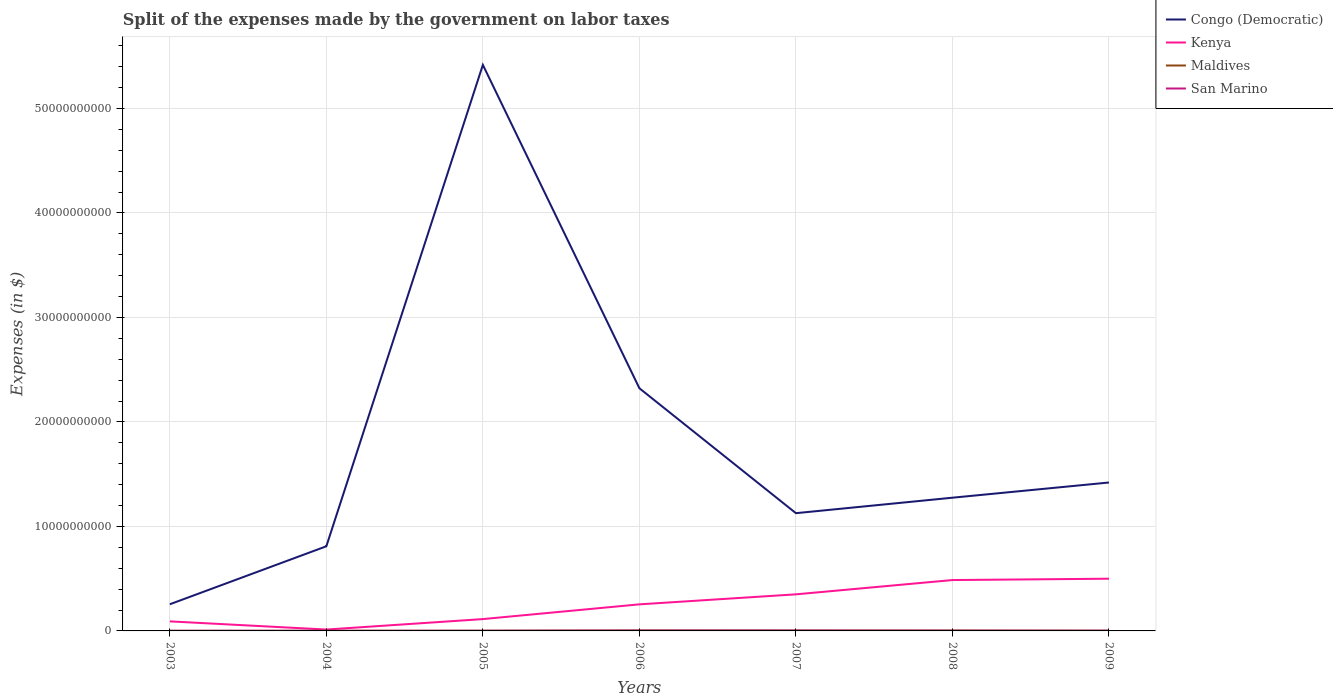Across all years, what is the maximum expenses made by the government on labor taxes in San Marino?
Keep it short and to the point. 1.21e+07. In which year was the expenses made by the government on labor taxes in Congo (Democratic) maximum?
Provide a succinct answer. 2003. What is the total expenses made by the government on labor taxes in San Marino in the graph?
Give a very brief answer. -1.90e+06. What is the difference between the highest and the second highest expenses made by the government on labor taxes in San Marino?
Your answer should be very brief. 1.99e+07. How many lines are there?
Provide a short and direct response. 4. Are the values on the major ticks of Y-axis written in scientific E-notation?
Ensure brevity in your answer.  No. How many legend labels are there?
Offer a very short reply. 4. What is the title of the graph?
Your response must be concise. Split of the expenses made by the government on labor taxes. Does "Latin America(developing only)" appear as one of the legend labels in the graph?
Offer a very short reply. No. What is the label or title of the X-axis?
Keep it short and to the point. Years. What is the label or title of the Y-axis?
Provide a short and direct response. Expenses (in $). What is the Expenses (in $) of Congo (Democratic) in 2003?
Ensure brevity in your answer.  2.55e+09. What is the Expenses (in $) of Kenya in 2003?
Your response must be concise. 9.14e+08. What is the Expenses (in $) of Maldives in 2003?
Your answer should be compact. 1.06e+07. What is the Expenses (in $) in San Marino in 2003?
Your answer should be very brief. 1.21e+07. What is the Expenses (in $) in Congo (Democratic) in 2004?
Offer a terse response. 8.10e+09. What is the Expenses (in $) in Kenya in 2004?
Keep it short and to the point. 1.31e+08. What is the Expenses (in $) of Maldives in 2004?
Give a very brief answer. 1.22e+07. What is the Expenses (in $) of San Marino in 2004?
Your response must be concise. 1.28e+07. What is the Expenses (in $) in Congo (Democratic) in 2005?
Give a very brief answer. 5.42e+1. What is the Expenses (in $) in Kenya in 2005?
Offer a very short reply. 1.13e+09. What is the Expenses (in $) of Maldives in 2005?
Give a very brief answer. 2.02e+07. What is the Expenses (in $) of San Marino in 2005?
Provide a succinct answer. 1.40e+07. What is the Expenses (in $) of Congo (Democratic) in 2006?
Your response must be concise. 2.32e+1. What is the Expenses (in $) in Kenya in 2006?
Keep it short and to the point. 2.54e+09. What is the Expenses (in $) in Maldives in 2006?
Ensure brevity in your answer.  4.56e+07. What is the Expenses (in $) in San Marino in 2006?
Your response must be concise. 2.84e+07. What is the Expenses (in $) of Congo (Democratic) in 2007?
Give a very brief answer. 1.13e+1. What is the Expenses (in $) of Kenya in 2007?
Give a very brief answer. 3.50e+09. What is the Expenses (in $) of Maldives in 2007?
Offer a terse response. 4.18e+07. What is the Expenses (in $) of San Marino in 2007?
Keep it short and to the point. 3.20e+07. What is the Expenses (in $) of Congo (Democratic) in 2008?
Your answer should be compact. 1.27e+1. What is the Expenses (in $) in Kenya in 2008?
Offer a very short reply. 4.87e+09. What is the Expenses (in $) of Maldives in 2008?
Your response must be concise. 3.97e+07. What is the Expenses (in $) of San Marino in 2008?
Make the answer very short. 1.87e+07. What is the Expenses (in $) in Congo (Democratic) in 2009?
Your answer should be compact. 1.42e+1. What is the Expenses (in $) in Kenya in 2009?
Offer a very short reply. 5.00e+09. What is the Expenses (in $) of Maldives in 2009?
Ensure brevity in your answer.  2.71e+07. What is the Expenses (in $) in San Marino in 2009?
Give a very brief answer. 1.88e+07. Across all years, what is the maximum Expenses (in $) in Congo (Democratic)?
Give a very brief answer. 5.42e+1. Across all years, what is the maximum Expenses (in $) of Kenya?
Your answer should be very brief. 5.00e+09. Across all years, what is the maximum Expenses (in $) of Maldives?
Give a very brief answer. 4.56e+07. Across all years, what is the maximum Expenses (in $) of San Marino?
Keep it short and to the point. 3.20e+07. Across all years, what is the minimum Expenses (in $) in Congo (Democratic)?
Offer a very short reply. 2.55e+09. Across all years, what is the minimum Expenses (in $) of Kenya?
Your answer should be very brief. 1.31e+08. Across all years, what is the minimum Expenses (in $) of Maldives?
Make the answer very short. 1.06e+07. Across all years, what is the minimum Expenses (in $) of San Marino?
Your response must be concise. 1.21e+07. What is the total Expenses (in $) in Congo (Democratic) in the graph?
Offer a terse response. 1.26e+11. What is the total Expenses (in $) of Kenya in the graph?
Offer a very short reply. 1.81e+1. What is the total Expenses (in $) of Maldives in the graph?
Your answer should be very brief. 1.97e+08. What is the total Expenses (in $) in San Marino in the graph?
Your response must be concise. 1.37e+08. What is the difference between the Expenses (in $) of Congo (Democratic) in 2003 and that in 2004?
Provide a succinct answer. -5.55e+09. What is the difference between the Expenses (in $) of Kenya in 2003 and that in 2004?
Your response must be concise. 7.83e+08. What is the difference between the Expenses (in $) in Maldives in 2003 and that in 2004?
Your answer should be compact. -1.60e+06. What is the difference between the Expenses (in $) of San Marino in 2003 and that in 2004?
Your answer should be compact. -7.01e+05. What is the difference between the Expenses (in $) in Congo (Democratic) in 2003 and that in 2005?
Offer a terse response. -5.16e+1. What is the difference between the Expenses (in $) of Kenya in 2003 and that in 2005?
Your answer should be compact. -2.19e+08. What is the difference between the Expenses (in $) in Maldives in 2003 and that in 2005?
Your answer should be compact. -9.60e+06. What is the difference between the Expenses (in $) in San Marino in 2003 and that in 2005?
Ensure brevity in your answer.  -1.90e+06. What is the difference between the Expenses (in $) of Congo (Democratic) in 2003 and that in 2006?
Ensure brevity in your answer.  -2.07e+1. What is the difference between the Expenses (in $) in Kenya in 2003 and that in 2006?
Give a very brief answer. -1.63e+09. What is the difference between the Expenses (in $) in Maldives in 2003 and that in 2006?
Offer a terse response. -3.50e+07. What is the difference between the Expenses (in $) in San Marino in 2003 and that in 2006?
Your response must be concise. -1.63e+07. What is the difference between the Expenses (in $) in Congo (Democratic) in 2003 and that in 2007?
Make the answer very short. -8.72e+09. What is the difference between the Expenses (in $) of Kenya in 2003 and that in 2007?
Provide a short and direct response. -2.59e+09. What is the difference between the Expenses (in $) in Maldives in 2003 and that in 2007?
Offer a very short reply. -3.12e+07. What is the difference between the Expenses (in $) of San Marino in 2003 and that in 2007?
Your answer should be compact. -1.99e+07. What is the difference between the Expenses (in $) in Congo (Democratic) in 2003 and that in 2008?
Ensure brevity in your answer.  -1.02e+1. What is the difference between the Expenses (in $) in Kenya in 2003 and that in 2008?
Offer a terse response. -3.95e+09. What is the difference between the Expenses (in $) of Maldives in 2003 and that in 2008?
Offer a terse response. -2.91e+07. What is the difference between the Expenses (in $) in San Marino in 2003 and that in 2008?
Ensure brevity in your answer.  -6.58e+06. What is the difference between the Expenses (in $) in Congo (Democratic) in 2003 and that in 2009?
Give a very brief answer. -1.17e+1. What is the difference between the Expenses (in $) of Kenya in 2003 and that in 2009?
Make the answer very short. -4.08e+09. What is the difference between the Expenses (in $) of Maldives in 2003 and that in 2009?
Your answer should be very brief. -1.65e+07. What is the difference between the Expenses (in $) of San Marino in 2003 and that in 2009?
Offer a terse response. -6.68e+06. What is the difference between the Expenses (in $) of Congo (Democratic) in 2004 and that in 2005?
Ensure brevity in your answer.  -4.61e+1. What is the difference between the Expenses (in $) of Kenya in 2004 and that in 2005?
Provide a short and direct response. -1.00e+09. What is the difference between the Expenses (in $) of Maldives in 2004 and that in 2005?
Ensure brevity in your answer.  -8.00e+06. What is the difference between the Expenses (in $) in San Marino in 2004 and that in 2005?
Make the answer very short. -1.20e+06. What is the difference between the Expenses (in $) in Congo (Democratic) in 2004 and that in 2006?
Provide a succinct answer. -1.51e+1. What is the difference between the Expenses (in $) in Kenya in 2004 and that in 2006?
Make the answer very short. -2.41e+09. What is the difference between the Expenses (in $) of Maldives in 2004 and that in 2006?
Provide a short and direct response. -3.34e+07. What is the difference between the Expenses (in $) in San Marino in 2004 and that in 2006?
Provide a succinct answer. -1.56e+07. What is the difference between the Expenses (in $) in Congo (Democratic) in 2004 and that in 2007?
Give a very brief answer. -3.17e+09. What is the difference between the Expenses (in $) of Kenya in 2004 and that in 2007?
Keep it short and to the point. -3.37e+09. What is the difference between the Expenses (in $) of Maldives in 2004 and that in 2007?
Give a very brief answer. -2.96e+07. What is the difference between the Expenses (in $) of San Marino in 2004 and that in 2007?
Offer a terse response. -1.92e+07. What is the difference between the Expenses (in $) of Congo (Democratic) in 2004 and that in 2008?
Your response must be concise. -4.65e+09. What is the difference between the Expenses (in $) of Kenya in 2004 and that in 2008?
Provide a succinct answer. -4.74e+09. What is the difference between the Expenses (in $) of Maldives in 2004 and that in 2008?
Ensure brevity in your answer.  -2.75e+07. What is the difference between the Expenses (in $) in San Marino in 2004 and that in 2008?
Provide a succinct answer. -5.88e+06. What is the difference between the Expenses (in $) in Congo (Democratic) in 2004 and that in 2009?
Provide a succinct answer. -6.10e+09. What is the difference between the Expenses (in $) in Kenya in 2004 and that in 2009?
Your answer should be compact. -4.87e+09. What is the difference between the Expenses (in $) of Maldives in 2004 and that in 2009?
Offer a terse response. -1.49e+07. What is the difference between the Expenses (in $) in San Marino in 2004 and that in 2009?
Ensure brevity in your answer.  -5.98e+06. What is the difference between the Expenses (in $) in Congo (Democratic) in 2005 and that in 2006?
Your answer should be very brief. 3.09e+1. What is the difference between the Expenses (in $) in Kenya in 2005 and that in 2006?
Provide a succinct answer. -1.41e+09. What is the difference between the Expenses (in $) of Maldives in 2005 and that in 2006?
Offer a terse response. -2.54e+07. What is the difference between the Expenses (in $) of San Marino in 2005 and that in 2006?
Offer a very short reply. -1.44e+07. What is the difference between the Expenses (in $) in Congo (Democratic) in 2005 and that in 2007?
Provide a succinct answer. 4.29e+1. What is the difference between the Expenses (in $) in Kenya in 2005 and that in 2007?
Your answer should be compact. -2.37e+09. What is the difference between the Expenses (in $) of Maldives in 2005 and that in 2007?
Give a very brief answer. -2.16e+07. What is the difference between the Expenses (in $) of San Marino in 2005 and that in 2007?
Your answer should be very brief. -1.80e+07. What is the difference between the Expenses (in $) in Congo (Democratic) in 2005 and that in 2008?
Make the answer very short. 4.14e+1. What is the difference between the Expenses (in $) in Kenya in 2005 and that in 2008?
Provide a succinct answer. -3.74e+09. What is the difference between the Expenses (in $) in Maldives in 2005 and that in 2008?
Provide a short and direct response. -1.95e+07. What is the difference between the Expenses (in $) of San Marino in 2005 and that in 2008?
Provide a succinct answer. -4.68e+06. What is the difference between the Expenses (in $) of Congo (Democratic) in 2005 and that in 2009?
Your response must be concise. 4.00e+1. What is the difference between the Expenses (in $) in Kenya in 2005 and that in 2009?
Offer a terse response. -3.86e+09. What is the difference between the Expenses (in $) of Maldives in 2005 and that in 2009?
Provide a succinct answer. -6.90e+06. What is the difference between the Expenses (in $) in San Marino in 2005 and that in 2009?
Keep it short and to the point. -4.78e+06. What is the difference between the Expenses (in $) in Congo (Democratic) in 2006 and that in 2007?
Offer a very short reply. 1.20e+1. What is the difference between the Expenses (in $) of Kenya in 2006 and that in 2007?
Ensure brevity in your answer.  -9.58e+08. What is the difference between the Expenses (in $) of Maldives in 2006 and that in 2007?
Provide a short and direct response. 3.80e+06. What is the difference between the Expenses (in $) in San Marino in 2006 and that in 2007?
Make the answer very short. -3.56e+06. What is the difference between the Expenses (in $) in Congo (Democratic) in 2006 and that in 2008?
Make the answer very short. 1.05e+1. What is the difference between the Expenses (in $) in Kenya in 2006 and that in 2008?
Your answer should be very brief. -2.33e+09. What is the difference between the Expenses (in $) of Maldives in 2006 and that in 2008?
Offer a terse response. 5.90e+06. What is the difference between the Expenses (in $) of San Marino in 2006 and that in 2008?
Make the answer very short. 9.73e+06. What is the difference between the Expenses (in $) of Congo (Democratic) in 2006 and that in 2009?
Offer a terse response. 9.02e+09. What is the difference between the Expenses (in $) of Kenya in 2006 and that in 2009?
Offer a very short reply. -2.45e+09. What is the difference between the Expenses (in $) of Maldives in 2006 and that in 2009?
Make the answer very short. 1.85e+07. What is the difference between the Expenses (in $) of San Marino in 2006 and that in 2009?
Your answer should be compact. 9.63e+06. What is the difference between the Expenses (in $) of Congo (Democratic) in 2007 and that in 2008?
Offer a very short reply. -1.48e+09. What is the difference between the Expenses (in $) of Kenya in 2007 and that in 2008?
Provide a short and direct response. -1.37e+09. What is the difference between the Expenses (in $) of Maldives in 2007 and that in 2008?
Your answer should be compact. 2.10e+06. What is the difference between the Expenses (in $) in San Marino in 2007 and that in 2008?
Offer a very short reply. 1.33e+07. What is the difference between the Expenses (in $) in Congo (Democratic) in 2007 and that in 2009?
Give a very brief answer. -2.93e+09. What is the difference between the Expenses (in $) of Kenya in 2007 and that in 2009?
Make the answer very short. -1.50e+09. What is the difference between the Expenses (in $) in Maldives in 2007 and that in 2009?
Your answer should be compact. 1.47e+07. What is the difference between the Expenses (in $) in San Marino in 2007 and that in 2009?
Your answer should be very brief. 1.32e+07. What is the difference between the Expenses (in $) in Congo (Democratic) in 2008 and that in 2009?
Provide a succinct answer. -1.45e+09. What is the difference between the Expenses (in $) of Kenya in 2008 and that in 2009?
Your answer should be compact. -1.29e+08. What is the difference between the Expenses (in $) in Maldives in 2008 and that in 2009?
Offer a very short reply. 1.26e+07. What is the difference between the Expenses (in $) of San Marino in 2008 and that in 2009?
Keep it short and to the point. -9.65e+04. What is the difference between the Expenses (in $) in Congo (Democratic) in 2003 and the Expenses (in $) in Kenya in 2004?
Offer a very short reply. 2.42e+09. What is the difference between the Expenses (in $) of Congo (Democratic) in 2003 and the Expenses (in $) of Maldives in 2004?
Make the answer very short. 2.54e+09. What is the difference between the Expenses (in $) of Congo (Democratic) in 2003 and the Expenses (in $) of San Marino in 2004?
Ensure brevity in your answer.  2.54e+09. What is the difference between the Expenses (in $) of Kenya in 2003 and the Expenses (in $) of Maldives in 2004?
Offer a very short reply. 9.01e+08. What is the difference between the Expenses (in $) of Kenya in 2003 and the Expenses (in $) of San Marino in 2004?
Give a very brief answer. 9.01e+08. What is the difference between the Expenses (in $) of Maldives in 2003 and the Expenses (in $) of San Marino in 2004?
Provide a succinct answer. -2.20e+06. What is the difference between the Expenses (in $) in Congo (Democratic) in 2003 and the Expenses (in $) in Kenya in 2005?
Give a very brief answer. 1.42e+09. What is the difference between the Expenses (in $) of Congo (Democratic) in 2003 and the Expenses (in $) of Maldives in 2005?
Give a very brief answer. 2.53e+09. What is the difference between the Expenses (in $) of Congo (Democratic) in 2003 and the Expenses (in $) of San Marino in 2005?
Your answer should be very brief. 2.54e+09. What is the difference between the Expenses (in $) of Kenya in 2003 and the Expenses (in $) of Maldives in 2005?
Your response must be concise. 8.93e+08. What is the difference between the Expenses (in $) in Kenya in 2003 and the Expenses (in $) in San Marino in 2005?
Give a very brief answer. 9.00e+08. What is the difference between the Expenses (in $) of Maldives in 2003 and the Expenses (in $) of San Marino in 2005?
Offer a terse response. -3.40e+06. What is the difference between the Expenses (in $) in Congo (Democratic) in 2003 and the Expenses (in $) in Kenya in 2006?
Offer a terse response. 7.52e+06. What is the difference between the Expenses (in $) in Congo (Democratic) in 2003 and the Expenses (in $) in Maldives in 2006?
Ensure brevity in your answer.  2.50e+09. What is the difference between the Expenses (in $) of Congo (Democratic) in 2003 and the Expenses (in $) of San Marino in 2006?
Make the answer very short. 2.52e+09. What is the difference between the Expenses (in $) of Kenya in 2003 and the Expenses (in $) of Maldives in 2006?
Provide a short and direct response. 8.68e+08. What is the difference between the Expenses (in $) of Kenya in 2003 and the Expenses (in $) of San Marino in 2006?
Offer a very short reply. 8.85e+08. What is the difference between the Expenses (in $) of Maldives in 2003 and the Expenses (in $) of San Marino in 2006?
Your answer should be compact. -1.78e+07. What is the difference between the Expenses (in $) in Congo (Democratic) in 2003 and the Expenses (in $) in Kenya in 2007?
Offer a terse response. -9.50e+08. What is the difference between the Expenses (in $) in Congo (Democratic) in 2003 and the Expenses (in $) in Maldives in 2007?
Your answer should be compact. 2.51e+09. What is the difference between the Expenses (in $) of Congo (Democratic) in 2003 and the Expenses (in $) of San Marino in 2007?
Your answer should be very brief. 2.52e+09. What is the difference between the Expenses (in $) in Kenya in 2003 and the Expenses (in $) in Maldives in 2007?
Make the answer very short. 8.72e+08. What is the difference between the Expenses (in $) in Kenya in 2003 and the Expenses (in $) in San Marino in 2007?
Your answer should be compact. 8.82e+08. What is the difference between the Expenses (in $) in Maldives in 2003 and the Expenses (in $) in San Marino in 2007?
Offer a terse response. -2.14e+07. What is the difference between the Expenses (in $) in Congo (Democratic) in 2003 and the Expenses (in $) in Kenya in 2008?
Ensure brevity in your answer.  -2.32e+09. What is the difference between the Expenses (in $) in Congo (Democratic) in 2003 and the Expenses (in $) in Maldives in 2008?
Offer a very short reply. 2.51e+09. What is the difference between the Expenses (in $) in Congo (Democratic) in 2003 and the Expenses (in $) in San Marino in 2008?
Keep it short and to the point. 2.53e+09. What is the difference between the Expenses (in $) in Kenya in 2003 and the Expenses (in $) in Maldives in 2008?
Offer a terse response. 8.74e+08. What is the difference between the Expenses (in $) in Kenya in 2003 and the Expenses (in $) in San Marino in 2008?
Offer a terse response. 8.95e+08. What is the difference between the Expenses (in $) of Maldives in 2003 and the Expenses (in $) of San Marino in 2008?
Provide a short and direct response. -8.08e+06. What is the difference between the Expenses (in $) of Congo (Democratic) in 2003 and the Expenses (in $) of Kenya in 2009?
Provide a succinct answer. -2.45e+09. What is the difference between the Expenses (in $) of Congo (Democratic) in 2003 and the Expenses (in $) of Maldives in 2009?
Provide a short and direct response. 2.52e+09. What is the difference between the Expenses (in $) of Congo (Democratic) in 2003 and the Expenses (in $) of San Marino in 2009?
Your response must be concise. 2.53e+09. What is the difference between the Expenses (in $) of Kenya in 2003 and the Expenses (in $) of Maldives in 2009?
Provide a short and direct response. 8.87e+08. What is the difference between the Expenses (in $) of Kenya in 2003 and the Expenses (in $) of San Marino in 2009?
Offer a terse response. 8.95e+08. What is the difference between the Expenses (in $) in Maldives in 2003 and the Expenses (in $) in San Marino in 2009?
Keep it short and to the point. -8.18e+06. What is the difference between the Expenses (in $) of Congo (Democratic) in 2004 and the Expenses (in $) of Kenya in 2005?
Offer a terse response. 6.97e+09. What is the difference between the Expenses (in $) of Congo (Democratic) in 2004 and the Expenses (in $) of Maldives in 2005?
Offer a terse response. 8.08e+09. What is the difference between the Expenses (in $) in Congo (Democratic) in 2004 and the Expenses (in $) in San Marino in 2005?
Ensure brevity in your answer.  8.08e+09. What is the difference between the Expenses (in $) in Kenya in 2004 and the Expenses (in $) in Maldives in 2005?
Make the answer very short. 1.11e+08. What is the difference between the Expenses (in $) in Kenya in 2004 and the Expenses (in $) in San Marino in 2005?
Offer a very short reply. 1.17e+08. What is the difference between the Expenses (in $) of Maldives in 2004 and the Expenses (in $) of San Marino in 2005?
Provide a short and direct response. -1.80e+06. What is the difference between the Expenses (in $) in Congo (Democratic) in 2004 and the Expenses (in $) in Kenya in 2006?
Give a very brief answer. 5.56e+09. What is the difference between the Expenses (in $) of Congo (Democratic) in 2004 and the Expenses (in $) of Maldives in 2006?
Your answer should be compact. 8.05e+09. What is the difference between the Expenses (in $) in Congo (Democratic) in 2004 and the Expenses (in $) in San Marino in 2006?
Your answer should be very brief. 8.07e+09. What is the difference between the Expenses (in $) of Kenya in 2004 and the Expenses (in $) of Maldives in 2006?
Your answer should be very brief. 8.54e+07. What is the difference between the Expenses (in $) of Kenya in 2004 and the Expenses (in $) of San Marino in 2006?
Ensure brevity in your answer.  1.03e+08. What is the difference between the Expenses (in $) in Maldives in 2004 and the Expenses (in $) in San Marino in 2006?
Your response must be concise. -1.62e+07. What is the difference between the Expenses (in $) of Congo (Democratic) in 2004 and the Expenses (in $) of Kenya in 2007?
Your response must be concise. 4.60e+09. What is the difference between the Expenses (in $) of Congo (Democratic) in 2004 and the Expenses (in $) of Maldives in 2007?
Provide a short and direct response. 8.06e+09. What is the difference between the Expenses (in $) of Congo (Democratic) in 2004 and the Expenses (in $) of San Marino in 2007?
Make the answer very short. 8.07e+09. What is the difference between the Expenses (in $) in Kenya in 2004 and the Expenses (in $) in Maldives in 2007?
Your answer should be very brief. 8.92e+07. What is the difference between the Expenses (in $) of Kenya in 2004 and the Expenses (in $) of San Marino in 2007?
Your answer should be very brief. 9.90e+07. What is the difference between the Expenses (in $) of Maldives in 2004 and the Expenses (in $) of San Marino in 2007?
Keep it short and to the point. -1.98e+07. What is the difference between the Expenses (in $) in Congo (Democratic) in 2004 and the Expenses (in $) in Kenya in 2008?
Your answer should be compact. 3.23e+09. What is the difference between the Expenses (in $) in Congo (Democratic) in 2004 and the Expenses (in $) in Maldives in 2008?
Provide a succinct answer. 8.06e+09. What is the difference between the Expenses (in $) of Congo (Democratic) in 2004 and the Expenses (in $) of San Marino in 2008?
Your response must be concise. 8.08e+09. What is the difference between the Expenses (in $) of Kenya in 2004 and the Expenses (in $) of Maldives in 2008?
Your answer should be very brief. 9.13e+07. What is the difference between the Expenses (in $) in Kenya in 2004 and the Expenses (in $) in San Marino in 2008?
Your answer should be very brief. 1.12e+08. What is the difference between the Expenses (in $) in Maldives in 2004 and the Expenses (in $) in San Marino in 2008?
Give a very brief answer. -6.48e+06. What is the difference between the Expenses (in $) in Congo (Democratic) in 2004 and the Expenses (in $) in Kenya in 2009?
Your answer should be compact. 3.10e+09. What is the difference between the Expenses (in $) in Congo (Democratic) in 2004 and the Expenses (in $) in Maldives in 2009?
Make the answer very short. 8.07e+09. What is the difference between the Expenses (in $) in Congo (Democratic) in 2004 and the Expenses (in $) in San Marino in 2009?
Ensure brevity in your answer.  8.08e+09. What is the difference between the Expenses (in $) in Kenya in 2004 and the Expenses (in $) in Maldives in 2009?
Your answer should be very brief. 1.04e+08. What is the difference between the Expenses (in $) of Kenya in 2004 and the Expenses (in $) of San Marino in 2009?
Ensure brevity in your answer.  1.12e+08. What is the difference between the Expenses (in $) of Maldives in 2004 and the Expenses (in $) of San Marino in 2009?
Provide a succinct answer. -6.58e+06. What is the difference between the Expenses (in $) in Congo (Democratic) in 2005 and the Expenses (in $) in Kenya in 2006?
Provide a succinct answer. 5.16e+1. What is the difference between the Expenses (in $) of Congo (Democratic) in 2005 and the Expenses (in $) of Maldives in 2006?
Your answer should be very brief. 5.41e+1. What is the difference between the Expenses (in $) in Congo (Democratic) in 2005 and the Expenses (in $) in San Marino in 2006?
Your response must be concise. 5.41e+1. What is the difference between the Expenses (in $) in Kenya in 2005 and the Expenses (in $) in Maldives in 2006?
Offer a very short reply. 1.09e+09. What is the difference between the Expenses (in $) in Kenya in 2005 and the Expenses (in $) in San Marino in 2006?
Provide a short and direct response. 1.10e+09. What is the difference between the Expenses (in $) in Maldives in 2005 and the Expenses (in $) in San Marino in 2006?
Give a very brief answer. -8.21e+06. What is the difference between the Expenses (in $) of Congo (Democratic) in 2005 and the Expenses (in $) of Kenya in 2007?
Your response must be concise. 5.07e+1. What is the difference between the Expenses (in $) in Congo (Democratic) in 2005 and the Expenses (in $) in Maldives in 2007?
Your answer should be very brief. 5.41e+1. What is the difference between the Expenses (in $) of Congo (Democratic) in 2005 and the Expenses (in $) of San Marino in 2007?
Provide a succinct answer. 5.41e+1. What is the difference between the Expenses (in $) in Kenya in 2005 and the Expenses (in $) in Maldives in 2007?
Your response must be concise. 1.09e+09. What is the difference between the Expenses (in $) of Kenya in 2005 and the Expenses (in $) of San Marino in 2007?
Offer a very short reply. 1.10e+09. What is the difference between the Expenses (in $) in Maldives in 2005 and the Expenses (in $) in San Marino in 2007?
Ensure brevity in your answer.  -1.18e+07. What is the difference between the Expenses (in $) in Congo (Democratic) in 2005 and the Expenses (in $) in Kenya in 2008?
Your answer should be compact. 4.93e+1. What is the difference between the Expenses (in $) in Congo (Democratic) in 2005 and the Expenses (in $) in Maldives in 2008?
Your response must be concise. 5.41e+1. What is the difference between the Expenses (in $) of Congo (Democratic) in 2005 and the Expenses (in $) of San Marino in 2008?
Offer a very short reply. 5.41e+1. What is the difference between the Expenses (in $) in Kenya in 2005 and the Expenses (in $) in Maldives in 2008?
Give a very brief answer. 1.09e+09. What is the difference between the Expenses (in $) of Kenya in 2005 and the Expenses (in $) of San Marino in 2008?
Provide a short and direct response. 1.11e+09. What is the difference between the Expenses (in $) in Maldives in 2005 and the Expenses (in $) in San Marino in 2008?
Make the answer very short. 1.52e+06. What is the difference between the Expenses (in $) in Congo (Democratic) in 2005 and the Expenses (in $) in Kenya in 2009?
Your response must be concise. 4.92e+1. What is the difference between the Expenses (in $) in Congo (Democratic) in 2005 and the Expenses (in $) in Maldives in 2009?
Make the answer very short. 5.41e+1. What is the difference between the Expenses (in $) of Congo (Democratic) in 2005 and the Expenses (in $) of San Marino in 2009?
Offer a very short reply. 5.41e+1. What is the difference between the Expenses (in $) of Kenya in 2005 and the Expenses (in $) of Maldives in 2009?
Offer a very short reply. 1.11e+09. What is the difference between the Expenses (in $) of Kenya in 2005 and the Expenses (in $) of San Marino in 2009?
Give a very brief answer. 1.11e+09. What is the difference between the Expenses (in $) of Maldives in 2005 and the Expenses (in $) of San Marino in 2009?
Provide a short and direct response. 1.42e+06. What is the difference between the Expenses (in $) in Congo (Democratic) in 2006 and the Expenses (in $) in Kenya in 2007?
Keep it short and to the point. 1.97e+1. What is the difference between the Expenses (in $) in Congo (Democratic) in 2006 and the Expenses (in $) in Maldives in 2007?
Ensure brevity in your answer.  2.32e+1. What is the difference between the Expenses (in $) in Congo (Democratic) in 2006 and the Expenses (in $) in San Marino in 2007?
Keep it short and to the point. 2.32e+1. What is the difference between the Expenses (in $) of Kenya in 2006 and the Expenses (in $) of Maldives in 2007?
Your answer should be compact. 2.50e+09. What is the difference between the Expenses (in $) in Kenya in 2006 and the Expenses (in $) in San Marino in 2007?
Ensure brevity in your answer.  2.51e+09. What is the difference between the Expenses (in $) of Maldives in 2006 and the Expenses (in $) of San Marino in 2007?
Provide a short and direct response. 1.36e+07. What is the difference between the Expenses (in $) of Congo (Democratic) in 2006 and the Expenses (in $) of Kenya in 2008?
Your response must be concise. 1.84e+1. What is the difference between the Expenses (in $) in Congo (Democratic) in 2006 and the Expenses (in $) in Maldives in 2008?
Give a very brief answer. 2.32e+1. What is the difference between the Expenses (in $) in Congo (Democratic) in 2006 and the Expenses (in $) in San Marino in 2008?
Offer a very short reply. 2.32e+1. What is the difference between the Expenses (in $) of Kenya in 2006 and the Expenses (in $) of Maldives in 2008?
Ensure brevity in your answer.  2.50e+09. What is the difference between the Expenses (in $) of Kenya in 2006 and the Expenses (in $) of San Marino in 2008?
Make the answer very short. 2.52e+09. What is the difference between the Expenses (in $) in Maldives in 2006 and the Expenses (in $) in San Marino in 2008?
Your answer should be compact. 2.69e+07. What is the difference between the Expenses (in $) in Congo (Democratic) in 2006 and the Expenses (in $) in Kenya in 2009?
Provide a short and direct response. 1.82e+1. What is the difference between the Expenses (in $) in Congo (Democratic) in 2006 and the Expenses (in $) in Maldives in 2009?
Keep it short and to the point. 2.32e+1. What is the difference between the Expenses (in $) in Congo (Democratic) in 2006 and the Expenses (in $) in San Marino in 2009?
Give a very brief answer. 2.32e+1. What is the difference between the Expenses (in $) in Kenya in 2006 and the Expenses (in $) in Maldives in 2009?
Offer a very short reply. 2.52e+09. What is the difference between the Expenses (in $) of Kenya in 2006 and the Expenses (in $) of San Marino in 2009?
Ensure brevity in your answer.  2.52e+09. What is the difference between the Expenses (in $) of Maldives in 2006 and the Expenses (in $) of San Marino in 2009?
Ensure brevity in your answer.  2.68e+07. What is the difference between the Expenses (in $) in Congo (Democratic) in 2007 and the Expenses (in $) in Kenya in 2008?
Keep it short and to the point. 6.40e+09. What is the difference between the Expenses (in $) in Congo (Democratic) in 2007 and the Expenses (in $) in Maldives in 2008?
Make the answer very short. 1.12e+1. What is the difference between the Expenses (in $) of Congo (Democratic) in 2007 and the Expenses (in $) of San Marino in 2008?
Ensure brevity in your answer.  1.12e+1. What is the difference between the Expenses (in $) in Kenya in 2007 and the Expenses (in $) in Maldives in 2008?
Offer a very short reply. 3.46e+09. What is the difference between the Expenses (in $) in Kenya in 2007 and the Expenses (in $) in San Marino in 2008?
Provide a short and direct response. 3.48e+09. What is the difference between the Expenses (in $) in Maldives in 2007 and the Expenses (in $) in San Marino in 2008?
Give a very brief answer. 2.31e+07. What is the difference between the Expenses (in $) in Congo (Democratic) in 2007 and the Expenses (in $) in Kenya in 2009?
Provide a succinct answer. 6.27e+09. What is the difference between the Expenses (in $) in Congo (Democratic) in 2007 and the Expenses (in $) in Maldives in 2009?
Your answer should be compact. 1.12e+1. What is the difference between the Expenses (in $) of Congo (Democratic) in 2007 and the Expenses (in $) of San Marino in 2009?
Offer a terse response. 1.12e+1. What is the difference between the Expenses (in $) of Kenya in 2007 and the Expenses (in $) of Maldives in 2009?
Give a very brief answer. 3.47e+09. What is the difference between the Expenses (in $) in Kenya in 2007 and the Expenses (in $) in San Marino in 2009?
Keep it short and to the point. 3.48e+09. What is the difference between the Expenses (in $) of Maldives in 2007 and the Expenses (in $) of San Marino in 2009?
Keep it short and to the point. 2.30e+07. What is the difference between the Expenses (in $) in Congo (Democratic) in 2008 and the Expenses (in $) in Kenya in 2009?
Provide a short and direct response. 7.75e+09. What is the difference between the Expenses (in $) of Congo (Democratic) in 2008 and the Expenses (in $) of Maldives in 2009?
Ensure brevity in your answer.  1.27e+1. What is the difference between the Expenses (in $) in Congo (Democratic) in 2008 and the Expenses (in $) in San Marino in 2009?
Your response must be concise. 1.27e+1. What is the difference between the Expenses (in $) of Kenya in 2008 and the Expenses (in $) of Maldives in 2009?
Offer a very short reply. 4.84e+09. What is the difference between the Expenses (in $) in Kenya in 2008 and the Expenses (in $) in San Marino in 2009?
Keep it short and to the point. 4.85e+09. What is the difference between the Expenses (in $) in Maldives in 2008 and the Expenses (in $) in San Marino in 2009?
Ensure brevity in your answer.  2.09e+07. What is the average Expenses (in $) in Congo (Democratic) per year?
Make the answer very short. 1.80e+1. What is the average Expenses (in $) of Kenya per year?
Offer a very short reply. 2.58e+09. What is the average Expenses (in $) in Maldives per year?
Keep it short and to the point. 2.82e+07. What is the average Expenses (in $) of San Marino per year?
Your answer should be compact. 1.95e+07. In the year 2003, what is the difference between the Expenses (in $) in Congo (Democratic) and Expenses (in $) in Kenya?
Offer a terse response. 1.64e+09. In the year 2003, what is the difference between the Expenses (in $) of Congo (Democratic) and Expenses (in $) of Maldives?
Your answer should be very brief. 2.54e+09. In the year 2003, what is the difference between the Expenses (in $) of Congo (Democratic) and Expenses (in $) of San Marino?
Offer a terse response. 2.54e+09. In the year 2003, what is the difference between the Expenses (in $) of Kenya and Expenses (in $) of Maldives?
Make the answer very short. 9.03e+08. In the year 2003, what is the difference between the Expenses (in $) of Kenya and Expenses (in $) of San Marino?
Your response must be concise. 9.02e+08. In the year 2003, what is the difference between the Expenses (in $) in Maldives and Expenses (in $) in San Marino?
Your answer should be very brief. -1.50e+06. In the year 2004, what is the difference between the Expenses (in $) of Congo (Democratic) and Expenses (in $) of Kenya?
Your response must be concise. 7.97e+09. In the year 2004, what is the difference between the Expenses (in $) of Congo (Democratic) and Expenses (in $) of Maldives?
Keep it short and to the point. 8.09e+09. In the year 2004, what is the difference between the Expenses (in $) in Congo (Democratic) and Expenses (in $) in San Marino?
Offer a terse response. 8.09e+09. In the year 2004, what is the difference between the Expenses (in $) of Kenya and Expenses (in $) of Maldives?
Keep it short and to the point. 1.19e+08. In the year 2004, what is the difference between the Expenses (in $) of Kenya and Expenses (in $) of San Marino?
Offer a terse response. 1.18e+08. In the year 2004, what is the difference between the Expenses (in $) of Maldives and Expenses (in $) of San Marino?
Make the answer very short. -6.00e+05. In the year 2005, what is the difference between the Expenses (in $) in Congo (Democratic) and Expenses (in $) in Kenya?
Keep it short and to the point. 5.30e+1. In the year 2005, what is the difference between the Expenses (in $) of Congo (Democratic) and Expenses (in $) of Maldives?
Offer a very short reply. 5.41e+1. In the year 2005, what is the difference between the Expenses (in $) in Congo (Democratic) and Expenses (in $) in San Marino?
Ensure brevity in your answer.  5.42e+1. In the year 2005, what is the difference between the Expenses (in $) in Kenya and Expenses (in $) in Maldives?
Keep it short and to the point. 1.11e+09. In the year 2005, what is the difference between the Expenses (in $) in Kenya and Expenses (in $) in San Marino?
Make the answer very short. 1.12e+09. In the year 2005, what is the difference between the Expenses (in $) in Maldives and Expenses (in $) in San Marino?
Provide a succinct answer. 6.20e+06. In the year 2006, what is the difference between the Expenses (in $) in Congo (Democratic) and Expenses (in $) in Kenya?
Offer a very short reply. 2.07e+1. In the year 2006, what is the difference between the Expenses (in $) of Congo (Democratic) and Expenses (in $) of Maldives?
Your answer should be very brief. 2.32e+1. In the year 2006, what is the difference between the Expenses (in $) in Congo (Democratic) and Expenses (in $) in San Marino?
Make the answer very short. 2.32e+1. In the year 2006, what is the difference between the Expenses (in $) in Kenya and Expenses (in $) in Maldives?
Keep it short and to the point. 2.50e+09. In the year 2006, what is the difference between the Expenses (in $) of Kenya and Expenses (in $) of San Marino?
Provide a short and direct response. 2.51e+09. In the year 2006, what is the difference between the Expenses (in $) in Maldives and Expenses (in $) in San Marino?
Make the answer very short. 1.72e+07. In the year 2007, what is the difference between the Expenses (in $) of Congo (Democratic) and Expenses (in $) of Kenya?
Offer a very short reply. 7.77e+09. In the year 2007, what is the difference between the Expenses (in $) of Congo (Democratic) and Expenses (in $) of Maldives?
Your response must be concise. 1.12e+1. In the year 2007, what is the difference between the Expenses (in $) in Congo (Democratic) and Expenses (in $) in San Marino?
Provide a short and direct response. 1.12e+1. In the year 2007, what is the difference between the Expenses (in $) of Kenya and Expenses (in $) of Maldives?
Your answer should be compact. 3.46e+09. In the year 2007, what is the difference between the Expenses (in $) of Kenya and Expenses (in $) of San Marino?
Ensure brevity in your answer.  3.47e+09. In the year 2007, what is the difference between the Expenses (in $) in Maldives and Expenses (in $) in San Marino?
Make the answer very short. 9.83e+06. In the year 2008, what is the difference between the Expenses (in $) of Congo (Democratic) and Expenses (in $) of Kenya?
Provide a short and direct response. 7.88e+09. In the year 2008, what is the difference between the Expenses (in $) of Congo (Democratic) and Expenses (in $) of Maldives?
Provide a short and direct response. 1.27e+1. In the year 2008, what is the difference between the Expenses (in $) in Congo (Democratic) and Expenses (in $) in San Marino?
Ensure brevity in your answer.  1.27e+1. In the year 2008, what is the difference between the Expenses (in $) of Kenya and Expenses (in $) of Maldives?
Your answer should be very brief. 4.83e+09. In the year 2008, what is the difference between the Expenses (in $) of Kenya and Expenses (in $) of San Marino?
Offer a very short reply. 4.85e+09. In the year 2008, what is the difference between the Expenses (in $) in Maldives and Expenses (in $) in San Marino?
Provide a succinct answer. 2.10e+07. In the year 2009, what is the difference between the Expenses (in $) in Congo (Democratic) and Expenses (in $) in Kenya?
Keep it short and to the point. 9.20e+09. In the year 2009, what is the difference between the Expenses (in $) in Congo (Democratic) and Expenses (in $) in Maldives?
Make the answer very short. 1.42e+1. In the year 2009, what is the difference between the Expenses (in $) of Congo (Democratic) and Expenses (in $) of San Marino?
Your answer should be very brief. 1.42e+1. In the year 2009, what is the difference between the Expenses (in $) of Kenya and Expenses (in $) of Maldives?
Provide a short and direct response. 4.97e+09. In the year 2009, what is the difference between the Expenses (in $) of Kenya and Expenses (in $) of San Marino?
Your response must be concise. 4.98e+09. In the year 2009, what is the difference between the Expenses (in $) of Maldives and Expenses (in $) of San Marino?
Offer a very short reply. 8.32e+06. What is the ratio of the Expenses (in $) in Congo (Democratic) in 2003 to that in 2004?
Offer a very short reply. 0.31. What is the ratio of the Expenses (in $) in Kenya in 2003 to that in 2004?
Your answer should be very brief. 6.97. What is the ratio of the Expenses (in $) of Maldives in 2003 to that in 2004?
Your response must be concise. 0.87. What is the ratio of the Expenses (in $) of San Marino in 2003 to that in 2004?
Give a very brief answer. 0.95. What is the ratio of the Expenses (in $) in Congo (Democratic) in 2003 to that in 2005?
Keep it short and to the point. 0.05. What is the ratio of the Expenses (in $) of Kenya in 2003 to that in 2005?
Offer a terse response. 0.81. What is the ratio of the Expenses (in $) of Maldives in 2003 to that in 2005?
Give a very brief answer. 0.52. What is the ratio of the Expenses (in $) in San Marino in 2003 to that in 2005?
Your response must be concise. 0.86. What is the ratio of the Expenses (in $) of Congo (Democratic) in 2003 to that in 2006?
Provide a succinct answer. 0.11. What is the ratio of the Expenses (in $) in Kenya in 2003 to that in 2006?
Provide a short and direct response. 0.36. What is the ratio of the Expenses (in $) of Maldives in 2003 to that in 2006?
Provide a succinct answer. 0.23. What is the ratio of the Expenses (in $) in San Marino in 2003 to that in 2006?
Make the answer very short. 0.43. What is the ratio of the Expenses (in $) in Congo (Democratic) in 2003 to that in 2007?
Make the answer very short. 0.23. What is the ratio of the Expenses (in $) of Kenya in 2003 to that in 2007?
Ensure brevity in your answer.  0.26. What is the ratio of the Expenses (in $) of Maldives in 2003 to that in 2007?
Your answer should be compact. 0.25. What is the ratio of the Expenses (in $) in San Marino in 2003 to that in 2007?
Ensure brevity in your answer.  0.38. What is the ratio of the Expenses (in $) of Congo (Democratic) in 2003 to that in 2008?
Offer a terse response. 0.2. What is the ratio of the Expenses (in $) of Kenya in 2003 to that in 2008?
Provide a succinct answer. 0.19. What is the ratio of the Expenses (in $) in Maldives in 2003 to that in 2008?
Provide a short and direct response. 0.27. What is the ratio of the Expenses (in $) of San Marino in 2003 to that in 2008?
Ensure brevity in your answer.  0.65. What is the ratio of the Expenses (in $) of Congo (Democratic) in 2003 to that in 2009?
Ensure brevity in your answer.  0.18. What is the ratio of the Expenses (in $) of Kenya in 2003 to that in 2009?
Your answer should be compact. 0.18. What is the ratio of the Expenses (in $) in Maldives in 2003 to that in 2009?
Your answer should be compact. 0.39. What is the ratio of the Expenses (in $) of San Marino in 2003 to that in 2009?
Give a very brief answer. 0.64. What is the ratio of the Expenses (in $) in Congo (Democratic) in 2004 to that in 2005?
Provide a short and direct response. 0.15. What is the ratio of the Expenses (in $) in Kenya in 2004 to that in 2005?
Your answer should be compact. 0.12. What is the ratio of the Expenses (in $) of Maldives in 2004 to that in 2005?
Your response must be concise. 0.6. What is the ratio of the Expenses (in $) in San Marino in 2004 to that in 2005?
Make the answer very short. 0.91. What is the ratio of the Expenses (in $) in Congo (Democratic) in 2004 to that in 2006?
Keep it short and to the point. 0.35. What is the ratio of the Expenses (in $) in Kenya in 2004 to that in 2006?
Give a very brief answer. 0.05. What is the ratio of the Expenses (in $) in Maldives in 2004 to that in 2006?
Provide a short and direct response. 0.27. What is the ratio of the Expenses (in $) of San Marino in 2004 to that in 2006?
Give a very brief answer. 0.45. What is the ratio of the Expenses (in $) of Congo (Democratic) in 2004 to that in 2007?
Provide a succinct answer. 0.72. What is the ratio of the Expenses (in $) of Kenya in 2004 to that in 2007?
Ensure brevity in your answer.  0.04. What is the ratio of the Expenses (in $) in Maldives in 2004 to that in 2007?
Give a very brief answer. 0.29. What is the ratio of the Expenses (in $) of San Marino in 2004 to that in 2007?
Your response must be concise. 0.4. What is the ratio of the Expenses (in $) of Congo (Democratic) in 2004 to that in 2008?
Your answer should be compact. 0.64. What is the ratio of the Expenses (in $) in Kenya in 2004 to that in 2008?
Offer a terse response. 0.03. What is the ratio of the Expenses (in $) of Maldives in 2004 to that in 2008?
Offer a very short reply. 0.31. What is the ratio of the Expenses (in $) in San Marino in 2004 to that in 2008?
Keep it short and to the point. 0.69. What is the ratio of the Expenses (in $) of Congo (Democratic) in 2004 to that in 2009?
Keep it short and to the point. 0.57. What is the ratio of the Expenses (in $) in Kenya in 2004 to that in 2009?
Make the answer very short. 0.03. What is the ratio of the Expenses (in $) of Maldives in 2004 to that in 2009?
Your answer should be very brief. 0.45. What is the ratio of the Expenses (in $) of San Marino in 2004 to that in 2009?
Your answer should be compact. 0.68. What is the ratio of the Expenses (in $) in Congo (Democratic) in 2005 to that in 2006?
Offer a terse response. 2.33. What is the ratio of the Expenses (in $) in Kenya in 2005 to that in 2006?
Provide a succinct answer. 0.45. What is the ratio of the Expenses (in $) of Maldives in 2005 to that in 2006?
Provide a succinct answer. 0.44. What is the ratio of the Expenses (in $) of San Marino in 2005 to that in 2006?
Ensure brevity in your answer.  0.49. What is the ratio of the Expenses (in $) of Congo (Democratic) in 2005 to that in 2007?
Make the answer very short. 4.81. What is the ratio of the Expenses (in $) in Kenya in 2005 to that in 2007?
Offer a terse response. 0.32. What is the ratio of the Expenses (in $) of Maldives in 2005 to that in 2007?
Give a very brief answer. 0.48. What is the ratio of the Expenses (in $) in San Marino in 2005 to that in 2007?
Your answer should be compact. 0.44. What is the ratio of the Expenses (in $) of Congo (Democratic) in 2005 to that in 2008?
Offer a terse response. 4.25. What is the ratio of the Expenses (in $) in Kenya in 2005 to that in 2008?
Your response must be concise. 0.23. What is the ratio of the Expenses (in $) in Maldives in 2005 to that in 2008?
Your response must be concise. 0.51. What is the ratio of the Expenses (in $) of San Marino in 2005 to that in 2008?
Offer a terse response. 0.75. What is the ratio of the Expenses (in $) of Congo (Democratic) in 2005 to that in 2009?
Your response must be concise. 3.81. What is the ratio of the Expenses (in $) of Kenya in 2005 to that in 2009?
Provide a succinct answer. 0.23. What is the ratio of the Expenses (in $) of Maldives in 2005 to that in 2009?
Your response must be concise. 0.75. What is the ratio of the Expenses (in $) in San Marino in 2005 to that in 2009?
Keep it short and to the point. 0.75. What is the ratio of the Expenses (in $) of Congo (Democratic) in 2006 to that in 2007?
Give a very brief answer. 2.06. What is the ratio of the Expenses (in $) of Kenya in 2006 to that in 2007?
Provide a short and direct response. 0.73. What is the ratio of the Expenses (in $) in San Marino in 2006 to that in 2007?
Your response must be concise. 0.89. What is the ratio of the Expenses (in $) of Congo (Democratic) in 2006 to that in 2008?
Offer a terse response. 1.82. What is the ratio of the Expenses (in $) of Kenya in 2006 to that in 2008?
Your answer should be compact. 0.52. What is the ratio of the Expenses (in $) of Maldives in 2006 to that in 2008?
Your answer should be very brief. 1.15. What is the ratio of the Expenses (in $) of San Marino in 2006 to that in 2008?
Offer a very short reply. 1.52. What is the ratio of the Expenses (in $) in Congo (Democratic) in 2006 to that in 2009?
Your answer should be compact. 1.64. What is the ratio of the Expenses (in $) in Kenya in 2006 to that in 2009?
Give a very brief answer. 0.51. What is the ratio of the Expenses (in $) in Maldives in 2006 to that in 2009?
Provide a short and direct response. 1.68. What is the ratio of the Expenses (in $) in San Marino in 2006 to that in 2009?
Offer a terse response. 1.51. What is the ratio of the Expenses (in $) of Congo (Democratic) in 2007 to that in 2008?
Provide a short and direct response. 0.88. What is the ratio of the Expenses (in $) of Kenya in 2007 to that in 2008?
Give a very brief answer. 0.72. What is the ratio of the Expenses (in $) of Maldives in 2007 to that in 2008?
Ensure brevity in your answer.  1.05. What is the ratio of the Expenses (in $) of San Marino in 2007 to that in 2008?
Your response must be concise. 1.71. What is the ratio of the Expenses (in $) of Congo (Democratic) in 2007 to that in 2009?
Provide a short and direct response. 0.79. What is the ratio of the Expenses (in $) in Kenya in 2007 to that in 2009?
Offer a very short reply. 0.7. What is the ratio of the Expenses (in $) in Maldives in 2007 to that in 2009?
Ensure brevity in your answer.  1.54. What is the ratio of the Expenses (in $) of San Marino in 2007 to that in 2009?
Provide a succinct answer. 1.7. What is the ratio of the Expenses (in $) of Congo (Democratic) in 2008 to that in 2009?
Your response must be concise. 0.9. What is the ratio of the Expenses (in $) of Kenya in 2008 to that in 2009?
Give a very brief answer. 0.97. What is the ratio of the Expenses (in $) of Maldives in 2008 to that in 2009?
Keep it short and to the point. 1.46. What is the difference between the highest and the second highest Expenses (in $) in Congo (Democratic)?
Keep it short and to the point. 3.09e+1. What is the difference between the highest and the second highest Expenses (in $) in Kenya?
Provide a short and direct response. 1.29e+08. What is the difference between the highest and the second highest Expenses (in $) in Maldives?
Make the answer very short. 3.80e+06. What is the difference between the highest and the second highest Expenses (in $) of San Marino?
Provide a short and direct response. 3.56e+06. What is the difference between the highest and the lowest Expenses (in $) in Congo (Democratic)?
Give a very brief answer. 5.16e+1. What is the difference between the highest and the lowest Expenses (in $) of Kenya?
Your answer should be compact. 4.87e+09. What is the difference between the highest and the lowest Expenses (in $) of Maldives?
Provide a succinct answer. 3.50e+07. What is the difference between the highest and the lowest Expenses (in $) in San Marino?
Provide a succinct answer. 1.99e+07. 